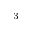Convert formula to latex. <formula><loc_0><loc_0><loc_500><loc_500>^ { 3 }</formula> 